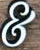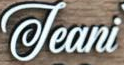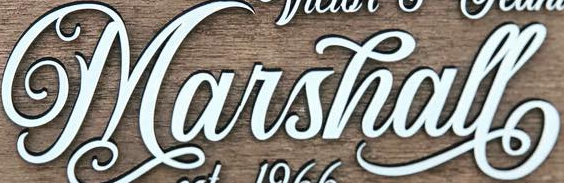Identify the words shown in these images in order, separated by a semicolon. &; Jeani; Marshall 